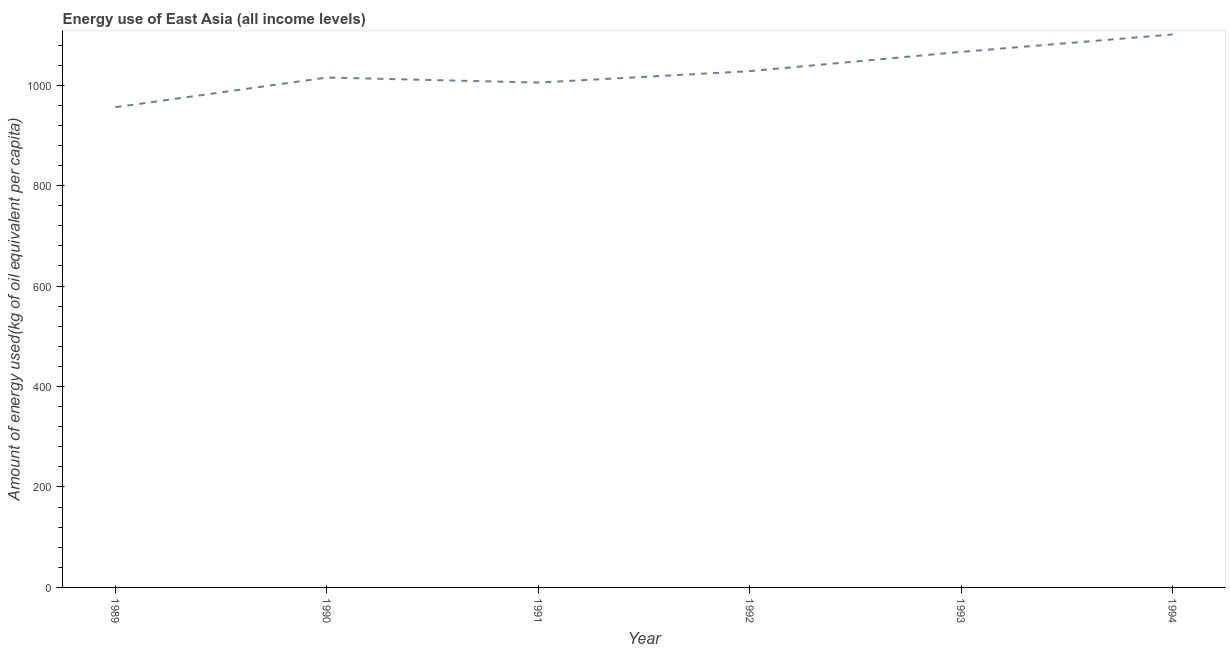What is the amount of energy used in 1992?
Offer a very short reply. 1027.95. Across all years, what is the maximum amount of energy used?
Keep it short and to the point. 1101.02. Across all years, what is the minimum amount of energy used?
Make the answer very short. 956.17. In which year was the amount of energy used minimum?
Offer a very short reply. 1989. What is the sum of the amount of energy used?
Offer a terse response. 6172.01. What is the difference between the amount of energy used in 1992 and 1993?
Your response must be concise. -38.41. What is the average amount of energy used per year?
Offer a terse response. 1028.67. What is the median amount of energy used?
Your answer should be compact. 1021.61. Do a majority of the years between 1994 and 1989 (inclusive) have amount of energy used greater than 320 kg?
Provide a succinct answer. Yes. What is the ratio of the amount of energy used in 1989 to that in 1991?
Your answer should be very brief. 0.95. What is the difference between the highest and the second highest amount of energy used?
Make the answer very short. 34.66. Is the sum of the amount of energy used in 1989 and 1991 greater than the maximum amount of energy used across all years?
Offer a terse response. Yes. What is the difference between the highest and the lowest amount of energy used?
Ensure brevity in your answer.  144.85. How many years are there in the graph?
Give a very brief answer. 6. What is the difference between two consecutive major ticks on the Y-axis?
Keep it short and to the point. 200. Does the graph contain any zero values?
Give a very brief answer. No. Does the graph contain grids?
Keep it short and to the point. No. What is the title of the graph?
Give a very brief answer. Energy use of East Asia (all income levels). What is the label or title of the Y-axis?
Your answer should be compact. Amount of energy used(kg of oil equivalent per capita). What is the Amount of energy used(kg of oil equivalent per capita) in 1989?
Provide a succinct answer. 956.17. What is the Amount of energy used(kg of oil equivalent per capita) in 1990?
Provide a succinct answer. 1015.27. What is the Amount of energy used(kg of oil equivalent per capita) in 1991?
Ensure brevity in your answer.  1005.26. What is the Amount of energy used(kg of oil equivalent per capita) of 1992?
Offer a terse response. 1027.95. What is the Amount of energy used(kg of oil equivalent per capita) in 1993?
Ensure brevity in your answer.  1066.36. What is the Amount of energy used(kg of oil equivalent per capita) in 1994?
Your answer should be compact. 1101.02. What is the difference between the Amount of energy used(kg of oil equivalent per capita) in 1989 and 1990?
Ensure brevity in your answer.  -59.1. What is the difference between the Amount of energy used(kg of oil equivalent per capita) in 1989 and 1991?
Offer a very short reply. -49.09. What is the difference between the Amount of energy used(kg of oil equivalent per capita) in 1989 and 1992?
Make the answer very short. -71.78. What is the difference between the Amount of energy used(kg of oil equivalent per capita) in 1989 and 1993?
Ensure brevity in your answer.  -110.19. What is the difference between the Amount of energy used(kg of oil equivalent per capita) in 1989 and 1994?
Your answer should be compact. -144.85. What is the difference between the Amount of energy used(kg of oil equivalent per capita) in 1990 and 1991?
Your answer should be compact. 10.01. What is the difference between the Amount of energy used(kg of oil equivalent per capita) in 1990 and 1992?
Offer a terse response. -12.68. What is the difference between the Amount of energy used(kg of oil equivalent per capita) in 1990 and 1993?
Provide a short and direct response. -51.09. What is the difference between the Amount of energy used(kg of oil equivalent per capita) in 1990 and 1994?
Ensure brevity in your answer.  -85.75. What is the difference between the Amount of energy used(kg of oil equivalent per capita) in 1991 and 1992?
Your answer should be compact. -22.69. What is the difference between the Amount of energy used(kg of oil equivalent per capita) in 1991 and 1993?
Make the answer very short. -61.1. What is the difference between the Amount of energy used(kg of oil equivalent per capita) in 1991 and 1994?
Your response must be concise. -95.76. What is the difference between the Amount of energy used(kg of oil equivalent per capita) in 1992 and 1993?
Offer a very short reply. -38.41. What is the difference between the Amount of energy used(kg of oil equivalent per capita) in 1992 and 1994?
Offer a terse response. -73.07. What is the difference between the Amount of energy used(kg of oil equivalent per capita) in 1993 and 1994?
Give a very brief answer. -34.66. What is the ratio of the Amount of energy used(kg of oil equivalent per capita) in 1989 to that in 1990?
Make the answer very short. 0.94. What is the ratio of the Amount of energy used(kg of oil equivalent per capita) in 1989 to that in 1991?
Give a very brief answer. 0.95. What is the ratio of the Amount of energy used(kg of oil equivalent per capita) in 1989 to that in 1993?
Ensure brevity in your answer.  0.9. What is the ratio of the Amount of energy used(kg of oil equivalent per capita) in 1989 to that in 1994?
Your response must be concise. 0.87. What is the ratio of the Amount of energy used(kg of oil equivalent per capita) in 1990 to that in 1991?
Offer a very short reply. 1.01. What is the ratio of the Amount of energy used(kg of oil equivalent per capita) in 1990 to that in 1992?
Provide a succinct answer. 0.99. What is the ratio of the Amount of energy used(kg of oil equivalent per capita) in 1990 to that in 1994?
Ensure brevity in your answer.  0.92. What is the ratio of the Amount of energy used(kg of oil equivalent per capita) in 1991 to that in 1992?
Offer a very short reply. 0.98. What is the ratio of the Amount of energy used(kg of oil equivalent per capita) in 1991 to that in 1993?
Offer a very short reply. 0.94. What is the ratio of the Amount of energy used(kg of oil equivalent per capita) in 1991 to that in 1994?
Offer a very short reply. 0.91. What is the ratio of the Amount of energy used(kg of oil equivalent per capita) in 1992 to that in 1994?
Your answer should be compact. 0.93. What is the ratio of the Amount of energy used(kg of oil equivalent per capita) in 1993 to that in 1994?
Make the answer very short. 0.97. 